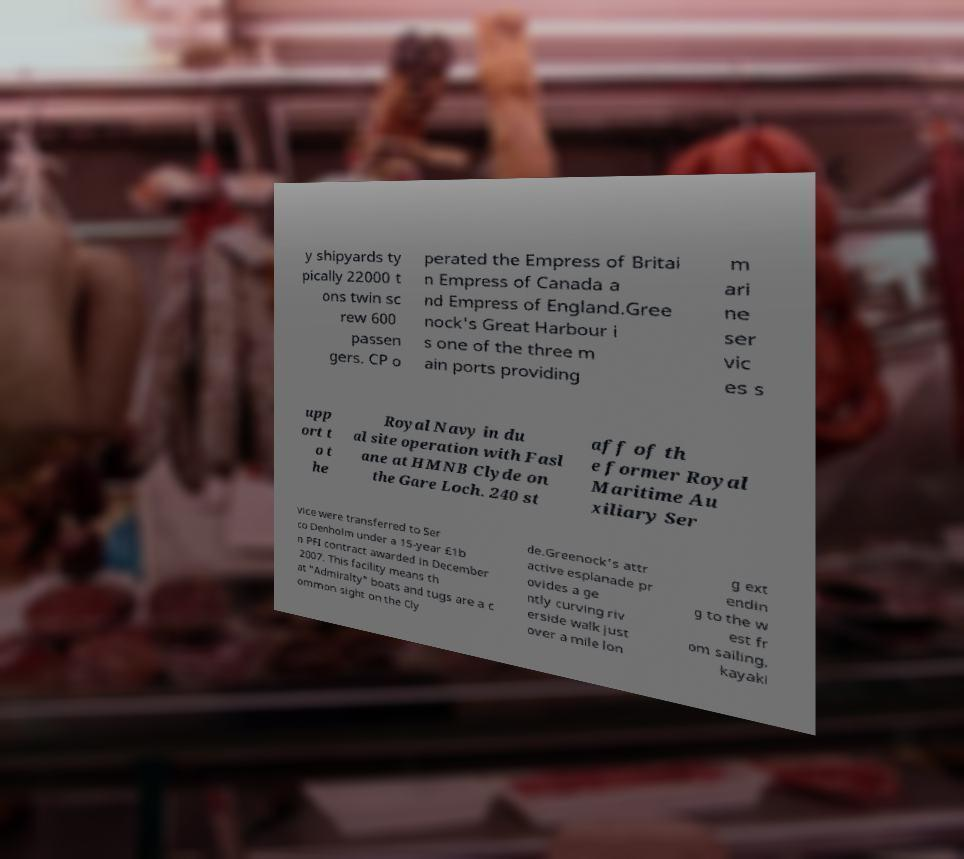Please read and relay the text visible in this image. What does it say? y shipyards ty pically 22000 t ons twin sc rew 600 passen gers. CP o perated the Empress of Britai n Empress of Canada a nd Empress of England.Gree nock's Great Harbour i s one of the three m ain ports providing m ari ne ser vic es s upp ort t o t he Royal Navy in du al site operation with Fasl ane at HMNB Clyde on the Gare Loch. 240 st aff of th e former Royal Maritime Au xiliary Ser vice were transferred to Ser co Denholm under a 15-year £1b n PFI contract awarded in December 2007. This facility means th at "Admiralty" boats and tugs are a c ommon sight on the Cly de.Greenock's attr active esplanade pr ovides a ge ntly curving riv erside walk just over a mile lon g ext endin g to the w est fr om sailing, kayaki 